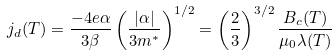<formula> <loc_0><loc_0><loc_500><loc_500>j _ { d } ( T ) = \frac { - 4 e \alpha } { 3 \beta } \left ( \frac { | \alpha | } { 3 m ^ { * } } \right ) ^ { 1 / 2 } = \left ( \frac { 2 } { 3 } \right ) ^ { 3 / 2 } \frac { B _ { c } ( T ) } { \mu _ { 0 } \lambda ( T ) }</formula> 